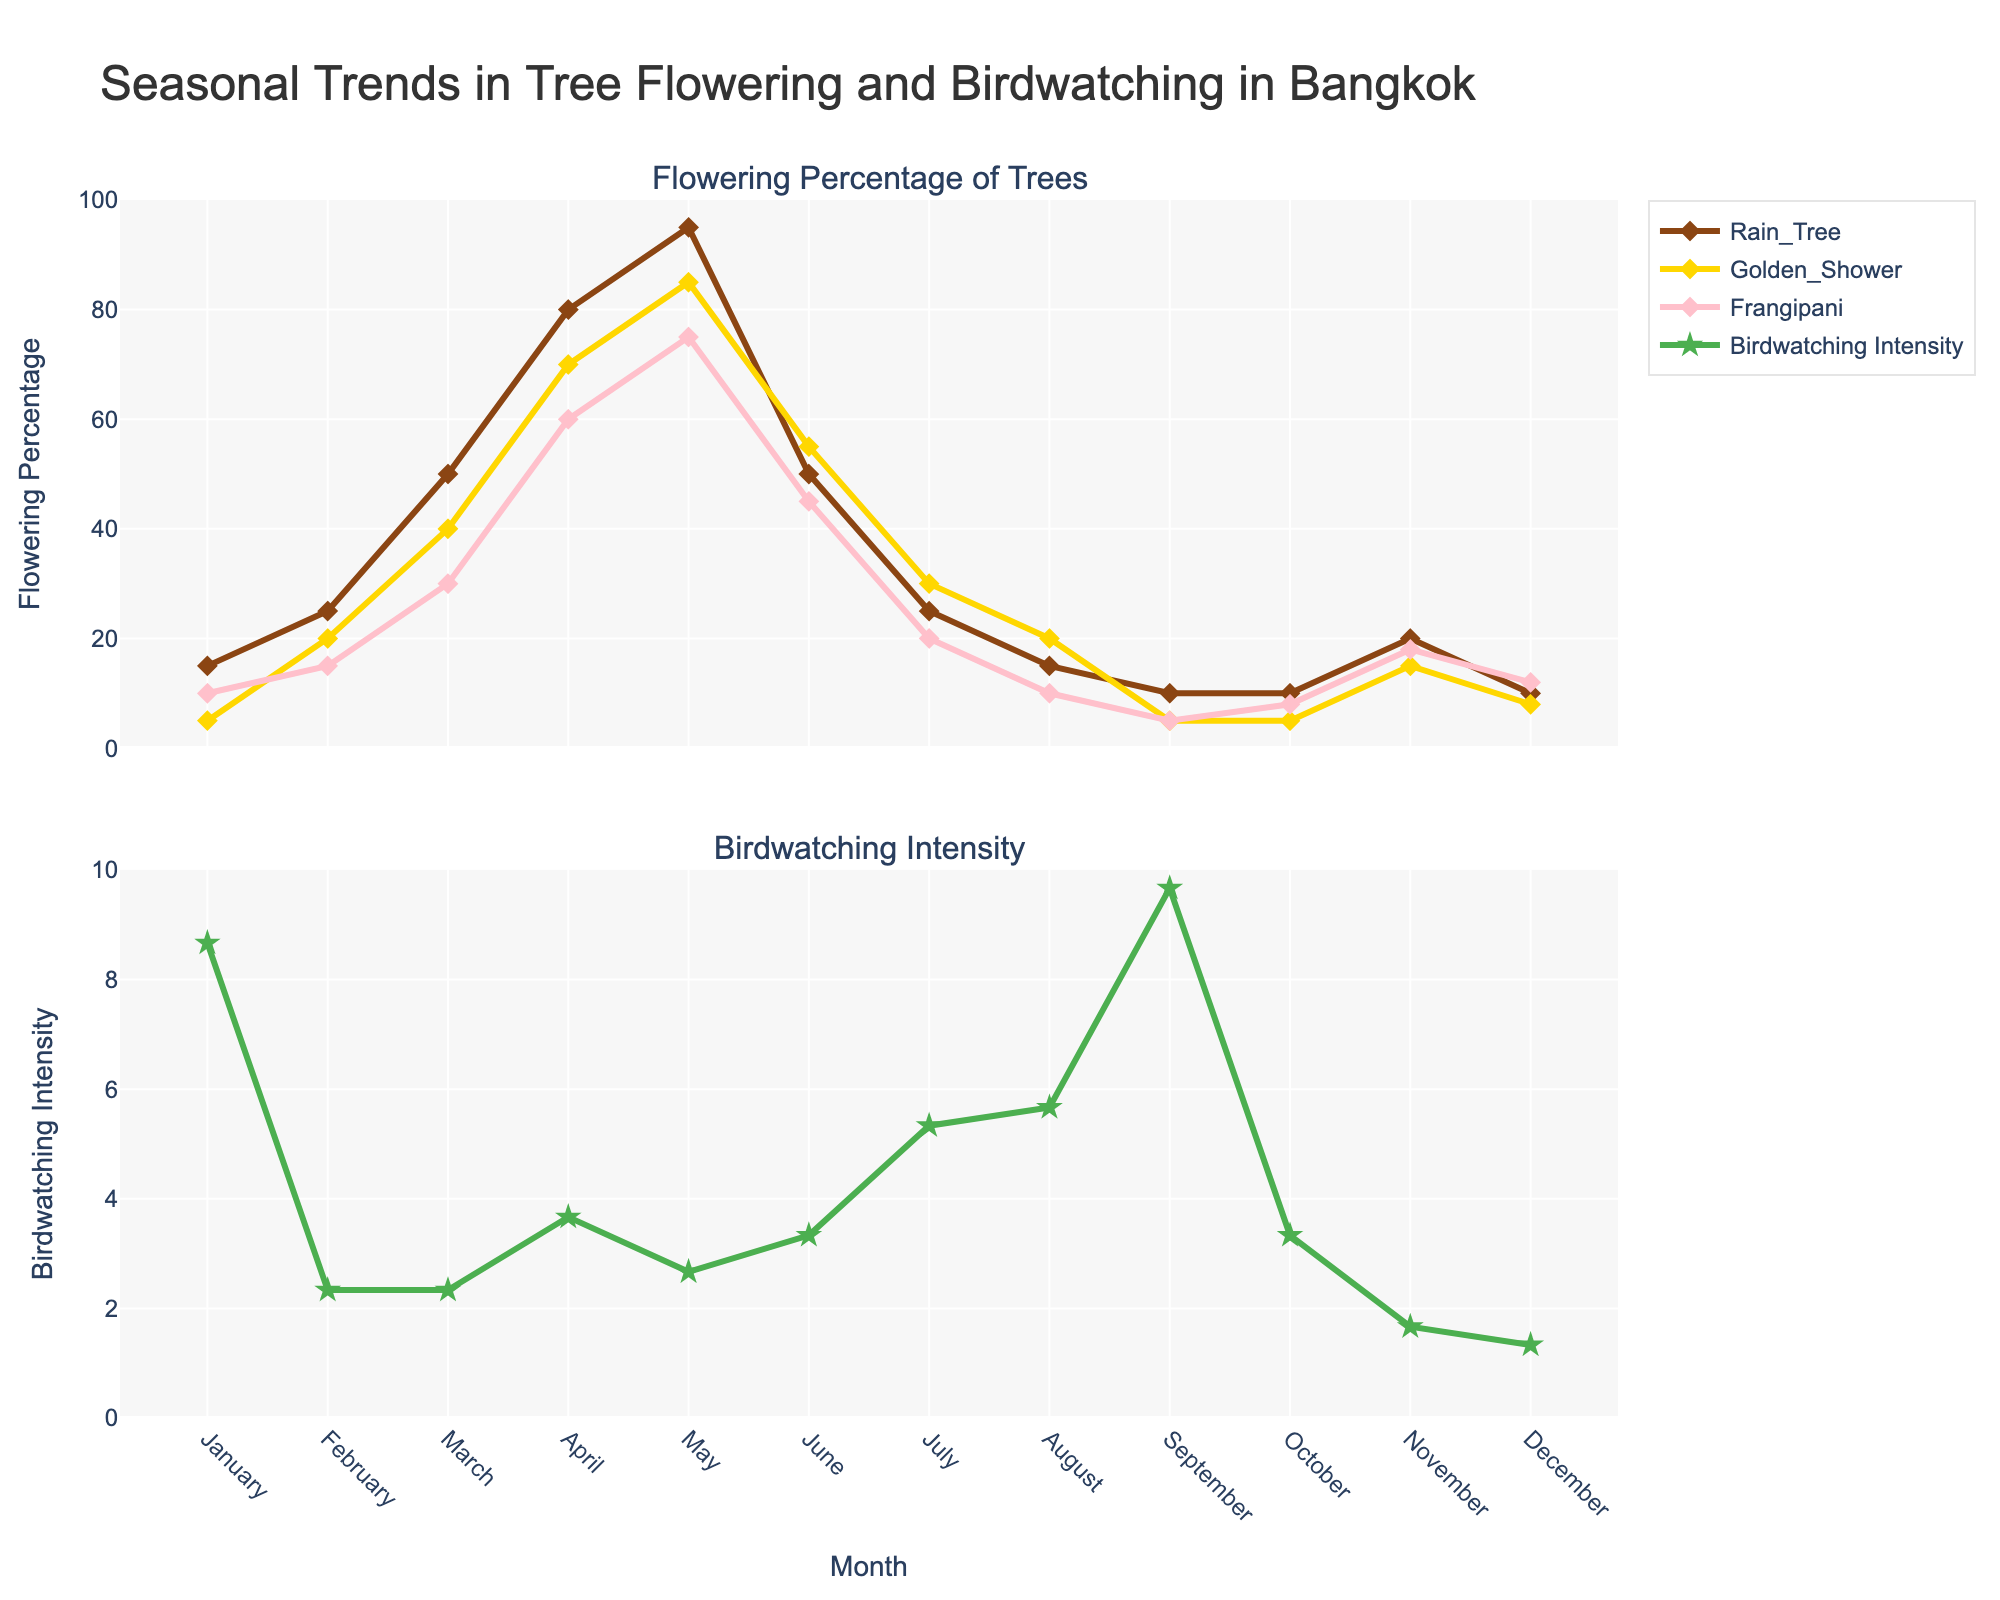What is the title of the figure? The title is usually placed at the top of the figure and is meant to give an overview of the plot. Here, the title is "Seasonal Trends in Tree Flowering and Birdwatching in Bangkok"
Answer: Seasonal Trends in Tree Flowering and Birdwatching in Bangkok What does the y-axis in the first subplot represent? The y-axis title of the first subplot is "Flowering Percentage," indicating the percentage of flowering for each tree species in Bangkok across different months.
Answer: Flowering Percentage Which month shows the highest birdwatching intensity? The plot for birdwatching intensity is in the second subplot. By observing the peaks, May has the highest birdwatching intensity with a value of 10.
Answer: May How does the flowering percentage of Rain Tree change from January to May? From January to May, the flowering percentage of Rain Tree increases progressively: January (15), February (25), March (50), April (80), and May (95). It shows a steady rise in flowering percentage.
Answer: It increases steadily In which months do Frangipani and Golden Shower have the same flowering percentage? By comparing the lines for Frangipani and Golden Shower, we see they both reach a flowering percentage of 10 in August.
Answer: August What is the average birdwatching intensity from January to December? Summing up the birdwatching intensity values for each month: 3+3+6+9+10+5+4+2+1+2+3+2 = 50, and dividing by the number of months (12): 50 / 12 ≈ 4.17
Answer: 4.17 Which tree species has the highest peak flowering percentage, and in which month? By inspecting the line peaks, Rain Tree has the highest peak flowering percentage of 95 in May.
Answer: Rain Tree in May Compare the flowering trend of Frangipani and Golden Shower throughout the year. Both Frangipani and Golden Shower have similar trends, starting low in January, peaking in May, and then decreasing. However, Golden Shower has generally higher percentages than Frangipani except in some months.
Answer: Golden Shower generally higher, similar trends Describe the relationship between birdwatching intensity and flowering percentage of tree species. There is a noticeable correlation where higher birdwatching intensity corresponds with higher flowering percentages, particularly around April and May when all tree species peak.
Answer: Higher birdwatching with higher flowering 